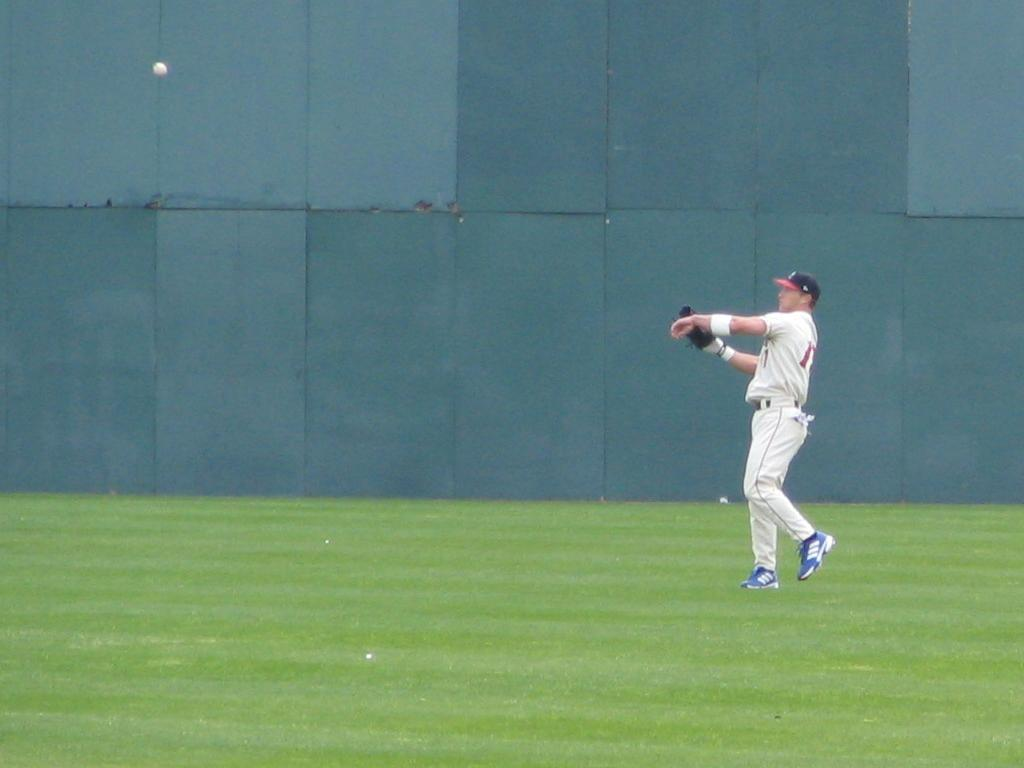What is the main subject of the image? There is a man in the image. What is the man doing in the image? The man is walking in the image. What is the man wearing in the image? The man is wearing clothes, shoes, and a cap in the image. What is the man holding in the image? The man is holding a glove in one hand in the image. What type of terrain is visible in the image? There is grass in the image. What object is present in the image that might be used for playing a game? There is a ball in the image. What structure is visible in the image? There is a wall in the image. What effect does the destruction of the wall have on the man in the image? There is no destruction of the wall in the image, so it is not possible to determine any effect on the man. 